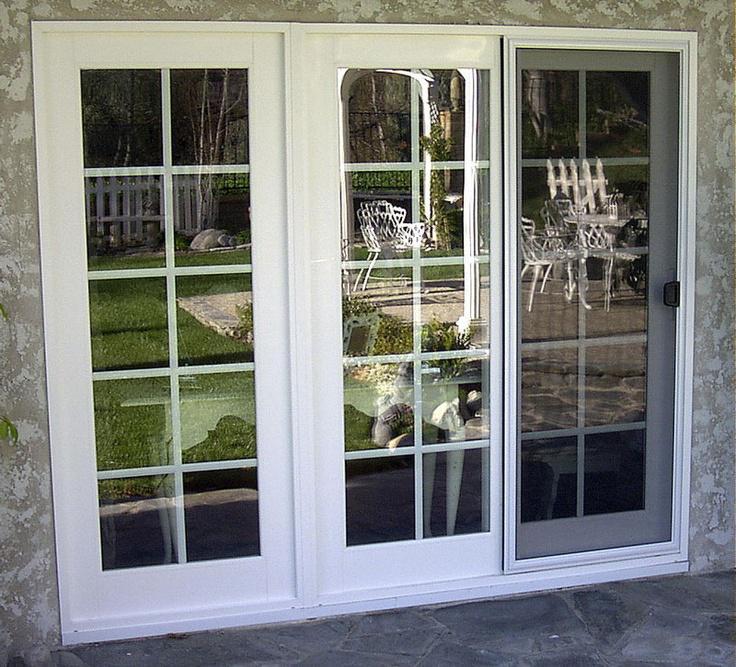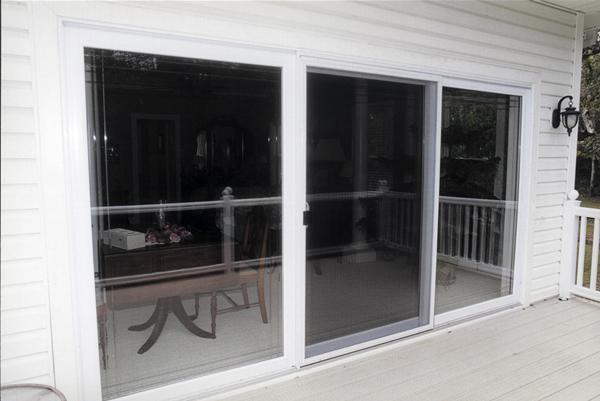The first image is the image on the left, the second image is the image on the right. For the images shown, is this caption "An image shows a square sliding glass unit with just two side-by-side glass panes." true? Answer yes or no. No. The first image is the image on the left, the second image is the image on the right. Analyze the images presented: Is the assertion "One door frame is white and the other is black." valid? Answer yes or no. No. 